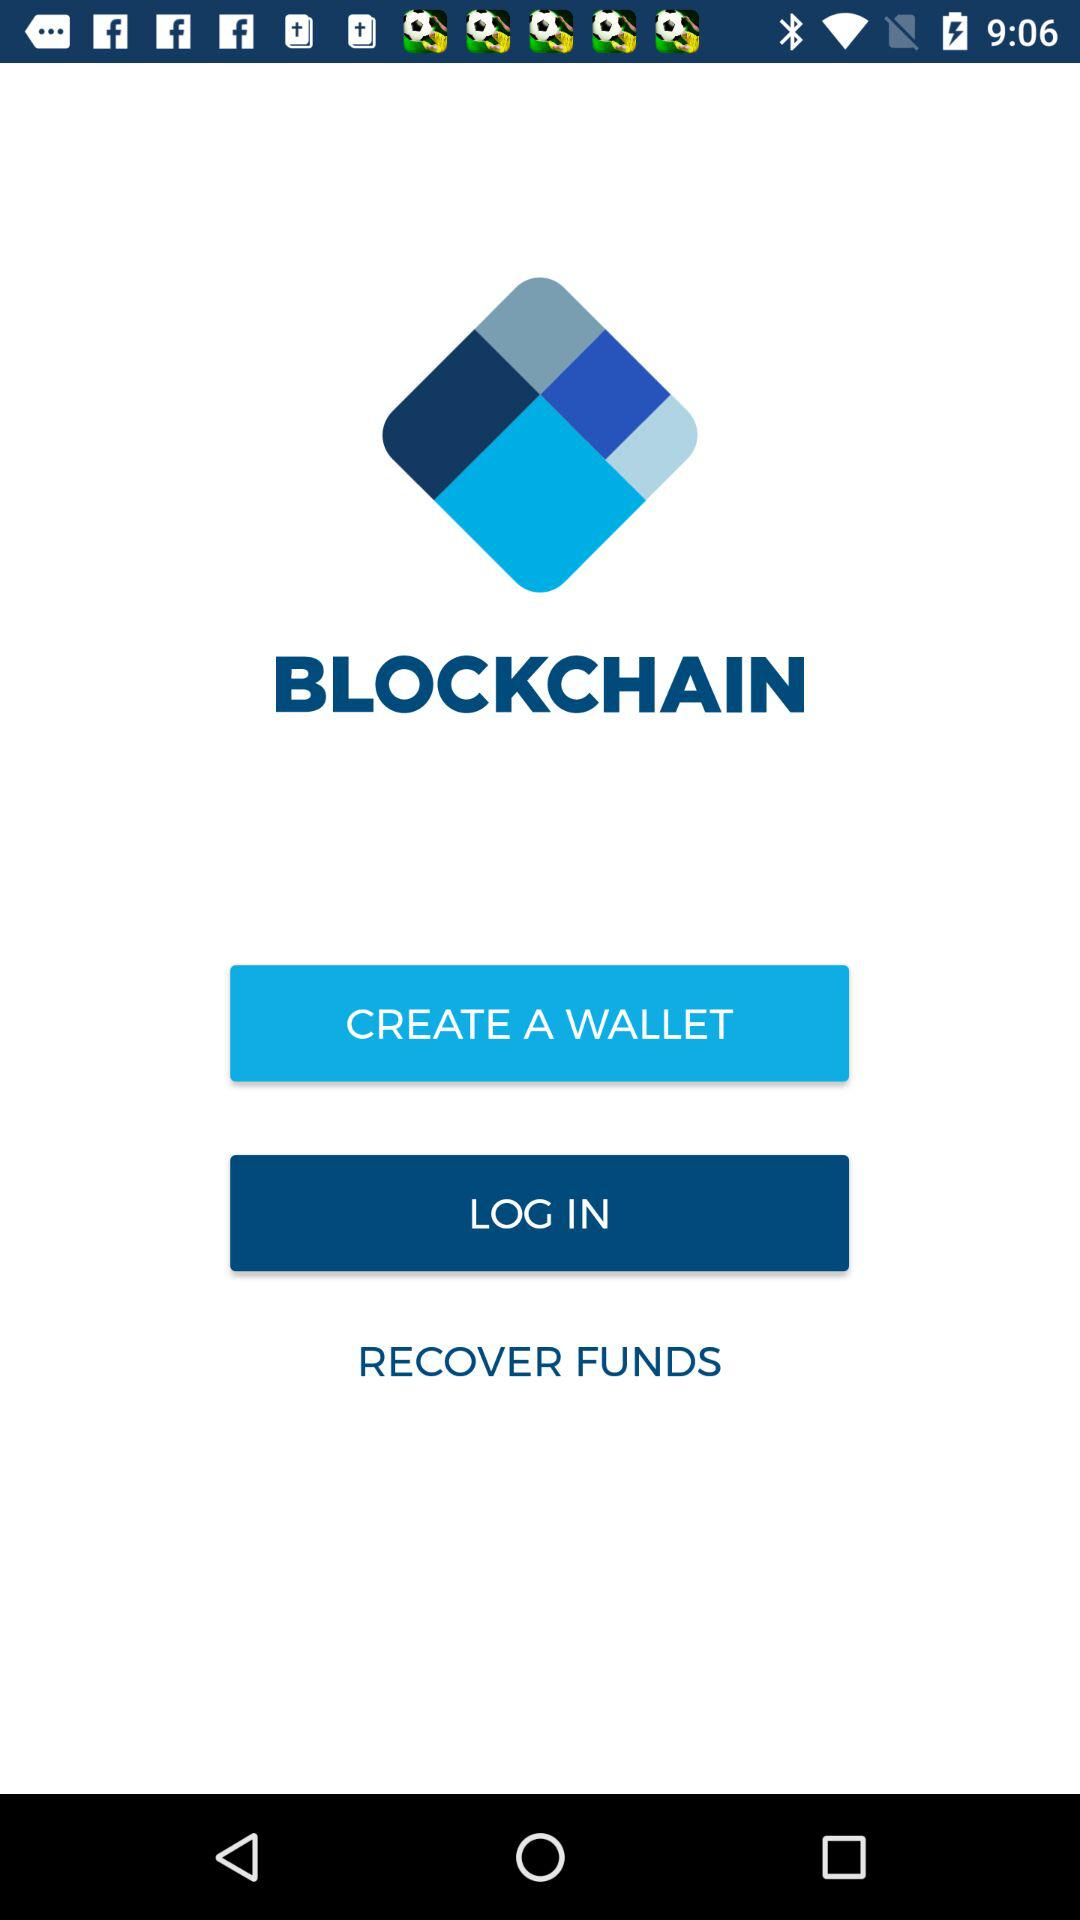What is the application name? The application name is "BLOCKCHAIN". 